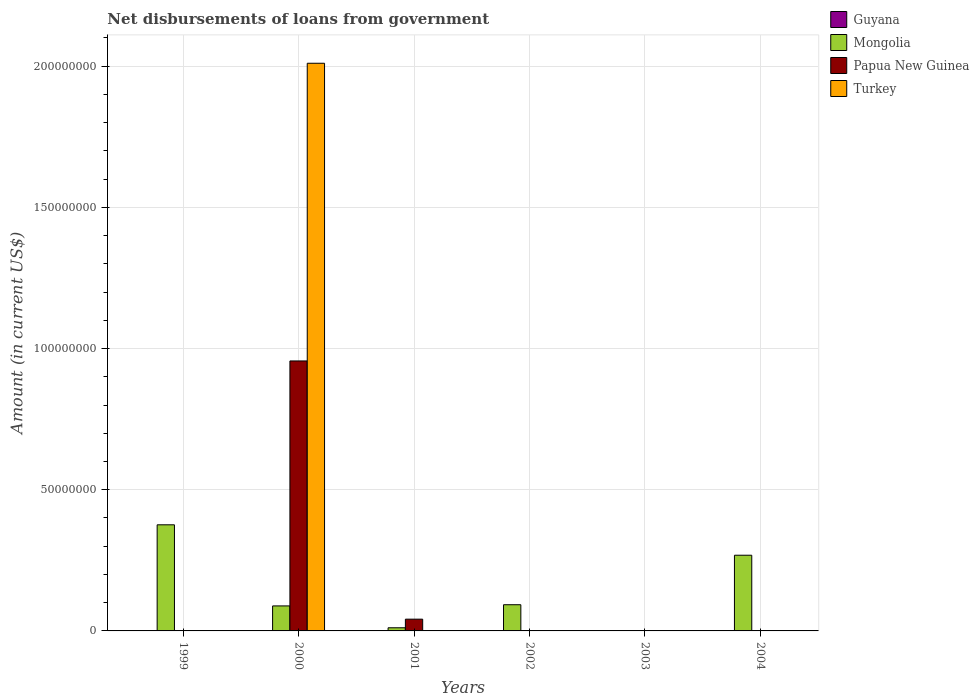How many different coloured bars are there?
Your response must be concise. 3. Are the number of bars per tick equal to the number of legend labels?
Keep it short and to the point. No. Are the number of bars on each tick of the X-axis equal?
Ensure brevity in your answer.  No. How many bars are there on the 5th tick from the left?
Keep it short and to the point. 0. What is the amount of loan disbursed from government in Turkey in 2003?
Your answer should be compact. 0. Across all years, what is the maximum amount of loan disbursed from government in Papua New Guinea?
Provide a short and direct response. 9.56e+07. What is the total amount of loan disbursed from government in Mongolia in the graph?
Your answer should be compact. 8.36e+07. What is the difference between the amount of loan disbursed from government in Mongolia in 1999 and that in 2004?
Give a very brief answer. 1.08e+07. What is the difference between the amount of loan disbursed from government in Papua New Guinea in 2000 and the amount of loan disbursed from government in Turkey in 2003?
Give a very brief answer. 9.56e+07. What is the average amount of loan disbursed from government in Papua New Guinea per year?
Your response must be concise. 1.66e+07. In the year 2000, what is the difference between the amount of loan disbursed from government in Mongolia and amount of loan disbursed from government in Turkey?
Your answer should be compact. -1.92e+08. In how many years, is the amount of loan disbursed from government in Papua New Guinea greater than 110000000 US$?
Your answer should be compact. 0. What is the ratio of the amount of loan disbursed from government in Papua New Guinea in 2000 to that in 2001?
Make the answer very short. 22.97. Is the amount of loan disbursed from government in Mongolia in 2001 less than that in 2002?
Provide a succinct answer. Yes. What is the difference between the highest and the second highest amount of loan disbursed from government in Mongolia?
Your answer should be compact. 1.08e+07. What is the difference between the highest and the lowest amount of loan disbursed from government in Papua New Guinea?
Ensure brevity in your answer.  9.56e+07. In how many years, is the amount of loan disbursed from government in Papua New Guinea greater than the average amount of loan disbursed from government in Papua New Guinea taken over all years?
Offer a terse response. 1. Is it the case that in every year, the sum of the amount of loan disbursed from government in Turkey and amount of loan disbursed from government in Mongolia is greater than the amount of loan disbursed from government in Guyana?
Your answer should be very brief. No. Are the values on the major ticks of Y-axis written in scientific E-notation?
Offer a very short reply. No. How many legend labels are there?
Offer a terse response. 4. What is the title of the graph?
Offer a terse response. Net disbursements of loans from government. What is the Amount (in current US$) in Guyana in 1999?
Provide a short and direct response. 0. What is the Amount (in current US$) in Mongolia in 1999?
Offer a very short reply. 3.76e+07. What is the Amount (in current US$) in Papua New Guinea in 1999?
Your answer should be very brief. 0. What is the Amount (in current US$) of Turkey in 1999?
Your answer should be very brief. 0. What is the Amount (in current US$) of Guyana in 2000?
Offer a very short reply. 0. What is the Amount (in current US$) of Mongolia in 2000?
Ensure brevity in your answer.  8.86e+06. What is the Amount (in current US$) in Papua New Guinea in 2000?
Your answer should be compact. 9.56e+07. What is the Amount (in current US$) of Turkey in 2000?
Provide a short and direct response. 2.01e+08. What is the Amount (in current US$) of Guyana in 2001?
Your answer should be very brief. 0. What is the Amount (in current US$) of Mongolia in 2001?
Give a very brief answer. 1.11e+06. What is the Amount (in current US$) of Papua New Guinea in 2001?
Keep it short and to the point. 4.16e+06. What is the Amount (in current US$) of Turkey in 2001?
Offer a terse response. 0. What is the Amount (in current US$) of Guyana in 2002?
Provide a short and direct response. 0. What is the Amount (in current US$) in Mongolia in 2002?
Ensure brevity in your answer.  9.28e+06. What is the Amount (in current US$) in Papua New Guinea in 2002?
Your answer should be compact. 0. What is the Amount (in current US$) of Turkey in 2002?
Make the answer very short. 0. What is the Amount (in current US$) in Guyana in 2003?
Your answer should be compact. 0. What is the Amount (in current US$) of Mongolia in 2004?
Keep it short and to the point. 2.68e+07. What is the Amount (in current US$) in Turkey in 2004?
Provide a succinct answer. 0. Across all years, what is the maximum Amount (in current US$) of Mongolia?
Make the answer very short. 3.76e+07. Across all years, what is the maximum Amount (in current US$) of Papua New Guinea?
Provide a succinct answer. 9.56e+07. Across all years, what is the maximum Amount (in current US$) of Turkey?
Keep it short and to the point. 2.01e+08. Across all years, what is the minimum Amount (in current US$) in Papua New Guinea?
Your answer should be very brief. 0. What is the total Amount (in current US$) in Mongolia in the graph?
Give a very brief answer. 8.36e+07. What is the total Amount (in current US$) of Papua New Guinea in the graph?
Your answer should be compact. 9.98e+07. What is the total Amount (in current US$) in Turkey in the graph?
Ensure brevity in your answer.  2.01e+08. What is the difference between the Amount (in current US$) in Mongolia in 1999 and that in 2000?
Provide a succinct answer. 2.87e+07. What is the difference between the Amount (in current US$) of Mongolia in 1999 and that in 2001?
Give a very brief answer. 3.65e+07. What is the difference between the Amount (in current US$) in Mongolia in 1999 and that in 2002?
Offer a terse response. 2.83e+07. What is the difference between the Amount (in current US$) of Mongolia in 1999 and that in 2004?
Offer a very short reply. 1.08e+07. What is the difference between the Amount (in current US$) of Mongolia in 2000 and that in 2001?
Your answer should be compact. 7.74e+06. What is the difference between the Amount (in current US$) in Papua New Guinea in 2000 and that in 2001?
Make the answer very short. 9.14e+07. What is the difference between the Amount (in current US$) of Mongolia in 2000 and that in 2002?
Give a very brief answer. -4.23e+05. What is the difference between the Amount (in current US$) of Mongolia in 2000 and that in 2004?
Offer a very short reply. -1.80e+07. What is the difference between the Amount (in current US$) of Mongolia in 2001 and that in 2002?
Give a very brief answer. -8.16e+06. What is the difference between the Amount (in current US$) of Mongolia in 2001 and that in 2004?
Your answer should be very brief. -2.57e+07. What is the difference between the Amount (in current US$) of Mongolia in 2002 and that in 2004?
Give a very brief answer. -1.75e+07. What is the difference between the Amount (in current US$) of Mongolia in 1999 and the Amount (in current US$) of Papua New Guinea in 2000?
Your response must be concise. -5.80e+07. What is the difference between the Amount (in current US$) in Mongolia in 1999 and the Amount (in current US$) in Turkey in 2000?
Ensure brevity in your answer.  -1.63e+08. What is the difference between the Amount (in current US$) of Mongolia in 1999 and the Amount (in current US$) of Papua New Guinea in 2001?
Make the answer very short. 3.34e+07. What is the difference between the Amount (in current US$) in Mongolia in 2000 and the Amount (in current US$) in Papua New Guinea in 2001?
Your answer should be compact. 4.69e+06. What is the average Amount (in current US$) in Mongolia per year?
Your answer should be compact. 1.39e+07. What is the average Amount (in current US$) of Papua New Guinea per year?
Ensure brevity in your answer.  1.66e+07. What is the average Amount (in current US$) in Turkey per year?
Your response must be concise. 3.35e+07. In the year 2000, what is the difference between the Amount (in current US$) in Mongolia and Amount (in current US$) in Papua New Guinea?
Provide a short and direct response. -8.67e+07. In the year 2000, what is the difference between the Amount (in current US$) in Mongolia and Amount (in current US$) in Turkey?
Give a very brief answer. -1.92e+08. In the year 2000, what is the difference between the Amount (in current US$) of Papua New Guinea and Amount (in current US$) of Turkey?
Offer a terse response. -1.05e+08. In the year 2001, what is the difference between the Amount (in current US$) of Mongolia and Amount (in current US$) of Papua New Guinea?
Provide a short and direct response. -3.05e+06. What is the ratio of the Amount (in current US$) in Mongolia in 1999 to that in 2000?
Provide a succinct answer. 4.24. What is the ratio of the Amount (in current US$) in Mongolia in 1999 to that in 2001?
Your answer should be compact. 33.73. What is the ratio of the Amount (in current US$) of Mongolia in 1999 to that in 2002?
Keep it short and to the point. 4.05. What is the ratio of the Amount (in current US$) of Mongolia in 1999 to that in 2004?
Your answer should be compact. 1.4. What is the ratio of the Amount (in current US$) in Mongolia in 2000 to that in 2001?
Your response must be concise. 7.95. What is the ratio of the Amount (in current US$) of Papua New Guinea in 2000 to that in 2001?
Your answer should be compact. 22.97. What is the ratio of the Amount (in current US$) in Mongolia in 2000 to that in 2002?
Provide a short and direct response. 0.95. What is the ratio of the Amount (in current US$) in Mongolia in 2000 to that in 2004?
Give a very brief answer. 0.33. What is the ratio of the Amount (in current US$) of Mongolia in 2001 to that in 2002?
Offer a very short reply. 0.12. What is the ratio of the Amount (in current US$) in Mongolia in 2001 to that in 2004?
Give a very brief answer. 0.04. What is the ratio of the Amount (in current US$) of Mongolia in 2002 to that in 2004?
Your answer should be very brief. 0.35. What is the difference between the highest and the second highest Amount (in current US$) of Mongolia?
Ensure brevity in your answer.  1.08e+07. What is the difference between the highest and the lowest Amount (in current US$) in Mongolia?
Your answer should be compact. 3.76e+07. What is the difference between the highest and the lowest Amount (in current US$) in Papua New Guinea?
Your answer should be very brief. 9.56e+07. What is the difference between the highest and the lowest Amount (in current US$) of Turkey?
Make the answer very short. 2.01e+08. 